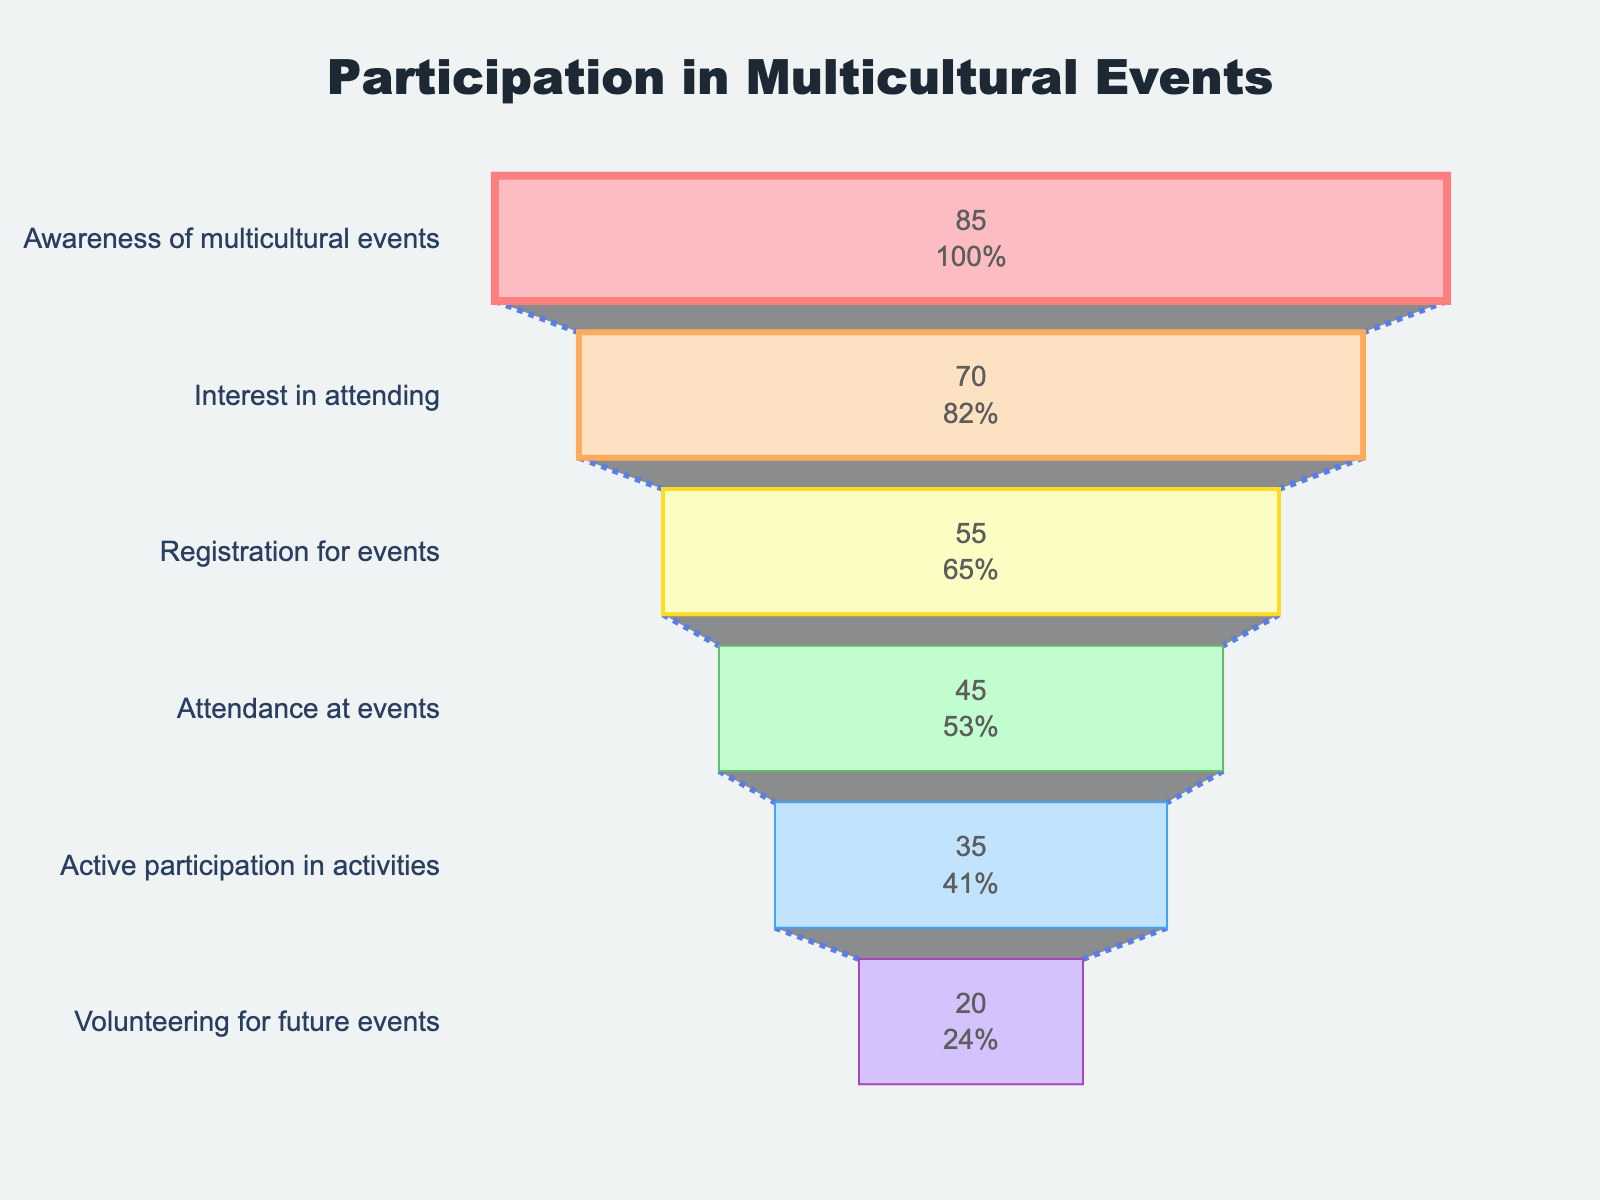How many stages are included in the funnel chart? The funnel chart contains several sections which represent different stages. By counting these sections, we obtain the total number of stages.
Answer: 6 Which stage has the largest drop in participation percentage from the previous stage? To find the largest drop, we need to calculate the difference in percentages between each consecutive stage and determine which difference is the largest. The drop from "Interest in attending" (70%) to "Registration for events" (55%) is 15%, which is the largest drop.
Answer: "Interest in attending" to "Registration for events" What percentage of participants who are aware of multicultural events actually attend the events? We start from the "Awareness of multicultural events" stage which is 85% and go to the "Attendance at events" stage which is 45%. The percentage of participants who attend the events is 45% of those who are aware.
Answer: 45% How much higher is the percentage for "Awareness of multicultural events" compared to "Volunteering for future events"? Calculate the difference between the percentages for these two stages: 85% (Awareness) - 20% (Volunteering) = 65%.
Answer: 65% Which stage has the fewest participants, and what is the percentage at this stage? By looking at the stage with the smallest percentage, we find that "Volunteering for future events" has the fewest participants at 20%.
Answer: "Volunteering for future events", 20% What is the percentage retention rate from "Registration for events" to "Active participation in activities"? Calculate the percentage of participants retained by comparing the stages: (35% / 55%) * 100 = approximately 63.64%.
Answer: 63.64% Which stage transition represents the lowest drop in participation? Find the smallest difference between consecutive stage percentages. The drop from "Attendance at events" (45%) to "Active participation in activities" (35%) is 10%, which is the smallest drop.
Answer: "Attendance at events" to "Active participation in activities" What is the primary focus of the funnel chart? The title of the funnel chart provides this information. The chart is about participation in multicultural events.
Answer: Participation in multicultural events 